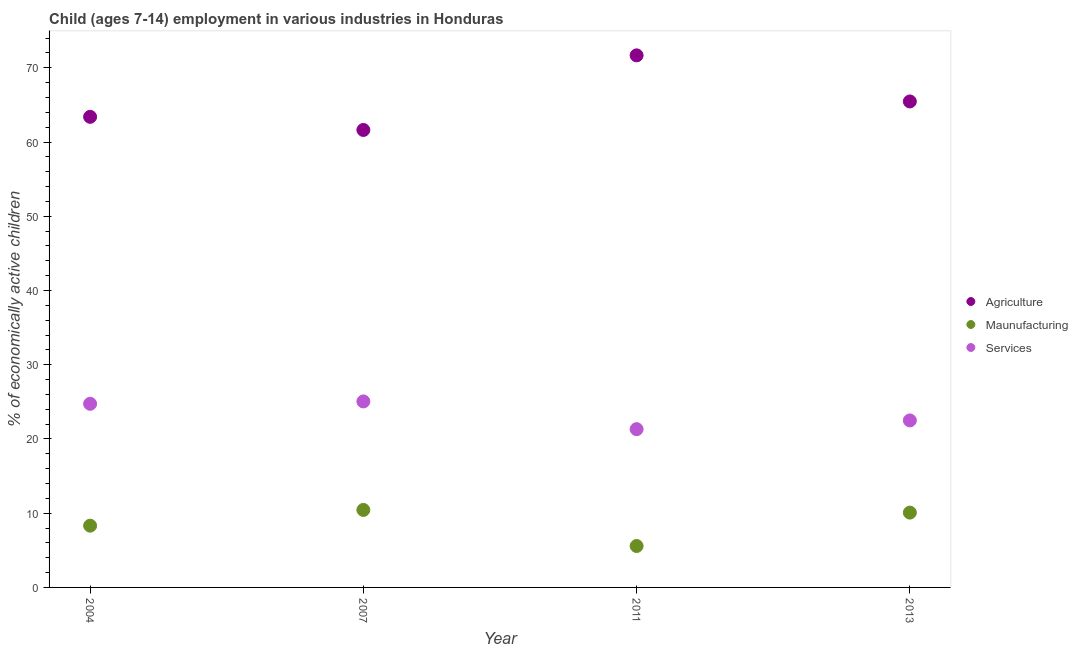How many different coloured dotlines are there?
Make the answer very short. 3. Is the number of dotlines equal to the number of legend labels?
Your response must be concise. Yes. What is the percentage of economically active children in agriculture in 2004?
Provide a short and direct response. 63.4. Across all years, what is the maximum percentage of economically active children in manufacturing?
Keep it short and to the point. 10.44. Across all years, what is the minimum percentage of economically active children in services?
Provide a short and direct response. 21.32. In which year was the percentage of economically active children in services minimum?
Offer a terse response. 2011. What is the total percentage of economically active children in agriculture in the graph?
Make the answer very short. 262.18. What is the difference between the percentage of economically active children in agriculture in 2004 and that in 2013?
Give a very brief answer. -2.07. What is the difference between the percentage of economically active children in manufacturing in 2011 and the percentage of economically active children in agriculture in 2013?
Your answer should be very brief. -59.89. What is the average percentage of economically active children in services per year?
Keep it short and to the point. 23.41. In the year 2004, what is the difference between the percentage of economically active children in services and percentage of economically active children in manufacturing?
Offer a very short reply. 16.42. In how many years, is the percentage of economically active children in services greater than 56 %?
Your answer should be compact. 0. What is the ratio of the percentage of economically active children in services in 2004 to that in 2011?
Offer a very short reply. 1.16. Is the difference between the percentage of economically active children in manufacturing in 2004 and 2011 greater than the difference between the percentage of economically active children in services in 2004 and 2011?
Keep it short and to the point. No. What is the difference between the highest and the second highest percentage of economically active children in agriculture?
Your response must be concise. 6.21. What is the difference between the highest and the lowest percentage of economically active children in agriculture?
Your answer should be compact. 10.05. Does the percentage of economically active children in manufacturing monotonically increase over the years?
Offer a very short reply. No. Is the percentage of economically active children in manufacturing strictly greater than the percentage of economically active children in agriculture over the years?
Keep it short and to the point. No. Is the percentage of economically active children in services strictly less than the percentage of economically active children in agriculture over the years?
Provide a short and direct response. Yes. How many dotlines are there?
Ensure brevity in your answer.  3. What is the difference between two consecutive major ticks on the Y-axis?
Provide a succinct answer. 10. Does the graph contain any zero values?
Offer a terse response. No. How many legend labels are there?
Give a very brief answer. 3. What is the title of the graph?
Provide a succinct answer. Child (ages 7-14) employment in various industries in Honduras. What is the label or title of the X-axis?
Your answer should be very brief. Year. What is the label or title of the Y-axis?
Your answer should be very brief. % of economically active children. What is the % of economically active children of Agriculture in 2004?
Give a very brief answer. 63.4. What is the % of economically active children of Maunufacturing in 2004?
Ensure brevity in your answer.  8.32. What is the % of economically active children of Services in 2004?
Your answer should be very brief. 24.74. What is the % of economically active children in Agriculture in 2007?
Provide a succinct answer. 61.63. What is the % of economically active children in Maunufacturing in 2007?
Your answer should be very brief. 10.44. What is the % of economically active children of Services in 2007?
Make the answer very short. 25.06. What is the % of economically active children in Agriculture in 2011?
Provide a succinct answer. 71.68. What is the % of economically active children of Maunufacturing in 2011?
Make the answer very short. 5.58. What is the % of economically active children of Services in 2011?
Ensure brevity in your answer.  21.32. What is the % of economically active children of Agriculture in 2013?
Your response must be concise. 65.47. What is the % of economically active children in Maunufacturing in 2013?
Your response must be concise. 10.08. Across all years, what is the maximum % of economically active children in Agriculture?
Your answer should be compact. 71.68. Across all years, what is the maximum % of economically active children in Maunufacturing?
Offer a terse response. 10.44. Across all years, what is the maximum % of economically active children in Services?
Provide a succinct answer. 25.06. Across all years, what is the minimum % of economically active children in Agriculture?
Make the answer very short. 61.63. Across all years, what is the minimum % of economically active children of Maunufacturing?
Ensure brevity in your answer.  5.58. Across all years, what is the minimum % of economically active children of Services?
Offer a very short reply. 21.32. What is the total % of economically active children in Agriculture in the graph?
Your response must be concise. 262.18. What is the total % of economically active children in Maunufacturing in the graph?
Provide a short and direct response. 34.42. What is the total % of economically active children of Services in the graph?
Ensure brevity in your answer.  93.62. What is the difference between the % of economically active children in Agriculture in 2004 and that in 2007?
Your response must be concise. 1.77. What is the difference between the % of economically active children of Maunufacturing in 2004 and that in 2007?
Provide a short and direct response. -2.12. What is the difference between the % of economically active children in Services in 2004 and that in 2007?
Make the answer very short. -0.32. What is the difference between the % of economically active children of Agriculture in 2004 and that in 2011?
Offer a terse response. -8.28. What is the difference between the % of economically active children in Maunufacturing in 2004 and that in 2011?
Ensure brevity in your answer.  2.74. What is the difference between the % of economically active children of Services in 2004 and that in 2011?
Keep it short and to the point. 3.42. What is the difference between the % of economically active children in Agriculture in 2004 and that in 2013?
Ensure brevity in your answer.  -2.07. What is the difference between the % of economically active children of Maunufacturing in 2004 and that in 2013?
Provide a short and direct response. -1.76. What is the difference between the % of economically active children of Services in 2004 and that in 2013?
Make the answer very short. 2.24. What is the difference between the % of economically active children in Agriculture in 2007 and that in 2011?
Your response must be concise. -10.05. What is the difference between the % of economically active children of Maunufacturing in 2007 and that in 2011?
Offer a very short reply. 4.86. What is the difference between the % of economically active children in Services in 2007 and that in 2011?
Make the answer very short. 3.74. What is the difference between the % of economically active children of Agriculture in 2007 and that in 2013?
Provide a short and direct response. -3.84. What is the difference between the % of economically active children of Maunufacturing in 2007 and that in 2013?
Ensure brevity in your answer.  0.36. What is the difference between the % of economically active children of Services in 2007 and that in 2013?
Your response must be concise. 2.56. What is the difference between the % of economically active children of Agriculture in 2011 and that in 2013?
Offer a terse response. 6.21. What is the difference between the % of economically active children of Services in 2011 and that in 2013?
Provide a short and direct response. -1.18. What is the difference between the % of economically active children of Agriculture in 2004 and the % of economically active children of Maunufacturing in 2007?
Your answer should be very brief. 52.96. What is the difference between the % of economically active children of Agriculture in 2004 and the % of economically active children of Services in 2007?
Provide a short and direct response. 38.34. What is the difference between the % of economically active children in Maunufacturing in 2004 and the % of economically active children in Services in 2007?
Offer a terse response. -16.74. What is the difference between the % of economically active children of Agriculture in 2004 and the % of economically active children of Maunufacturing in 2011?
Ensure brevity in your answer.  57.82. What is the difference between the % of economically active children of Agriculture in 2004 and the % of economically active children of Services in 2011?
Ensure brevity in your answer.  42.08. What is the difference between the % of economically active children in Maunufacturing in 2004 and the % of economically active children in Services in 2011?
Provide a succinct answer. -13. What is the difference between the % of economically active children in Agriculture in 2004 and the % of economically active children in Maunufacturing in 2013?
Provide a short and direct response. 53.32. What is the difference between the % of economically active children in Agriculture in 2004 and the % of economically active children in Services in 2013?
Make the answer very short. 40.9. What is the difference between the % of economically active children in Maunufacturing in 2004 and the % of economically active children in Services in 2013?
Offer a terse response. -14.18. What is the difference between the % of economically active children in Agriculture in 2007 and the % of economically active children in Maunufacturing in 2011?
Your answer should be compact. 56.05. What is the difference between the % of economically active children in Agriculture in 2007 and the % of economically active children in Services in 2011?
Make the answer very short. 40.31. What is the difference between the % of economically active children in Maunufacturing in 2007 and the % of economically active children in Services in 2011?
Offer a terse response. -10.88. What is the difference between the % of economically active children in Agriculture in 2007 and the % of economically active children in Maunufacturing in 2013?
Provide a succinct answer. 51.55. What is the difference between the % of economically active children in Agriculture in 2007 and the % of economically active children in Services in 2013?
Your response must be concise. 39.13. What is the difference between the % of economically active children in Maunufacturing in 2007 and the % of economically active children in Services in 2013?
Keep it short and to the point. -12.06. What is the difference between the % of economically active children of Agriculture in 2011 and the % of economically active children of Maunufacturing in 2013?
Your response must be concise. 61.6. What is the difference between the % of economically active children of Agriculture in 2011 and the % of economically active children of Services in 2013?
Make the answer very short. 49.18. What is the difference between the % of economically active children of Maunufacturing in 2011 and the % of economically active children of Services in 2013?
Make the answer very short. -16.92. What is the average % of economically active children of Agriculture per year?
Provide a short and direct response. 65.55. What is the average % of economically active children in Maunufacturing per year?
Offer a terse response. 8.61. What is the average % of economically active children in Services per year?
Ensure brevity in your answer.  23.41. In the year 2004, what is the difference between the % of economically active children in Agriculture and % of economically active children in Maunufacturing?
Give a very brief answer. 55.08. In the year 2004, what is the difference between the % of economically active children of Agriculture and % of economically active children of Services?
Keep it short and to the point. 38.66. In the year 2004, what is the difference between the % of economically active children in Maunufacturing and % of economically active children in Services?
Offer a terse response. -16.42. In the year 2007, what is the difference between the % of economically active children of Agriculture and % of economically active children of Maunufacturing?
Provide a short and direct response. 51.19. In the year 2007, what is the difference between the % of economically active children of Agriculture and % of economically active children of Services?
Your answer should be very brief. 36.57. In the year 2007, what is the difference between the % of economically active children of Maunufacturing and % of economically active children of Services?
Make the answer very short. -14.62. In the year 2011, what is the difference between the % of economically active children of Agriculture and % of economically active children of Maunufacturing?
Keep it short and to the point. 66.1. In the year 2011, what is the difference between the % of economically active children of Agriculture and % of economically active children of Services?
Your answer should be very brief. 50.36. In the year 2011, what is the difference between the % of economically active children in Maunufacturing and % of economically active children in Services?
Keep it short and to the point. -15.74. In the year 2013, what is the difference between the % of economically active children of Agriculture and % of economically active children of Maunufacturing?
Provide a short and direct response. 55.39. In the year 2013, what is the difference between the % of economically active children of Agriculture and % of economically active children of Services?
Provide a succinct answer. 42.97. In the year 2013, what is the difference between the % of economically active children of Maunufacturing and % of economically active children of Services?
Provide a short and direct response. -12.42. What is the ratio of the % of economically active children in Agriculture in 2004 to that in 2007?
Offer a terse response. 1.03. What is the ratio of the % of economically active children in Maunufacturing in 2004 to that in 2007?
Offer a terse response. 0.8. What is the ratio of the % of economically active children in Services in 2004 to that in 2007?
Ensure brevity in your answer.  0.99. What is the ratio of the % of economically active children in Agriculture in 2004 to that in 2011?
Give a very brief answer. 0.88. What is the ratio of the % of economically active children of Maunufacturing in 2004 to that in 2011?
Provide a short and direct response. 1.49. What is the ratio of the % of economically active children in Services in 2004 to that in 2011?
Provide a succinct answer. 1.16. What is the ratio of the % of economically active children of Agriculture in 2004 to that in 2013?
Keep it short and to the point. 0.97. What is the ratio of the % of economically active children in Maunufacturing in 2004 to that in 2013?
Keep it short and to the point. 0.83. What is the ratio of the % of economically active children in Services in 2004 to that in 2013?
Give a very brief answer. 1.1. What is the ratio of the % of economically active children of Agriculture in 2007 to that in 2011?
Offer a very short reply. 0.86. What is the ratio of the % of economically active children in Maunufacturing in 2007 to that in 2011?
Your response must be concise. 1.87. What is the ratio of the % of economically active children in Services in 2007 to that in 2011?
Keep it short and to the point. 1.18. What is the ratio of the % of economically active children of Agriculture in 2007 to that in 2013?
Give a very brief answer. 0.94. What is the ratio of the % of economically active children of Maunufacturing in 2007 to that in 2013?
Offer a terse response. 1.04. What is the ratio of the % of economically active children of Services in 2007 to that in 2013?
Your answer should be compact. 1.11. What is the ratio of the % of economically active children of Agriculture in 2011 to that in 2013?
Your response must be concise. 1.09. What is the ratio of the % of economically active children in Maunufacturing in 2011 to that in 2013?
Provide a succinct answer. 0.55. What is the ratio of the % of economically active children of Services in 2011 to that in 2013?
Your response must be concise. 0.95. What is the difference between the highest and the second highest % of economically active children of Agriculture?
Keep it short and to the point. 6.21. What is the difference between the highest and the second highest % of economically active children of Maunufacturing?
Your answer should be compact. 0.36. What is the difference between the highest and the second highest % of economically active children in Services?
Your response must be concise. 0.32. What is the difference between the highest and the lowest % of economically active children of Agriculture?
Offer a very short reply. 10.05. What is the difference between the highest and the lowest % of economically active children of Maunufacturing?
Provide a short and direct response. 4.86. What is the difference between the highest and the lowest % of economically active children of Services?
Your answer should be compact. 3.74. 